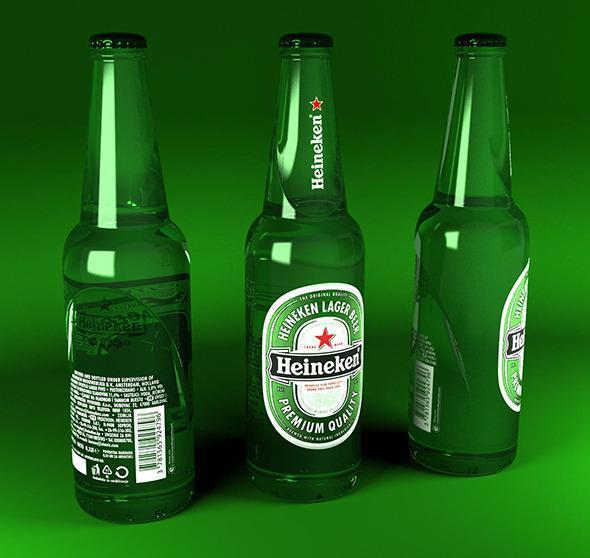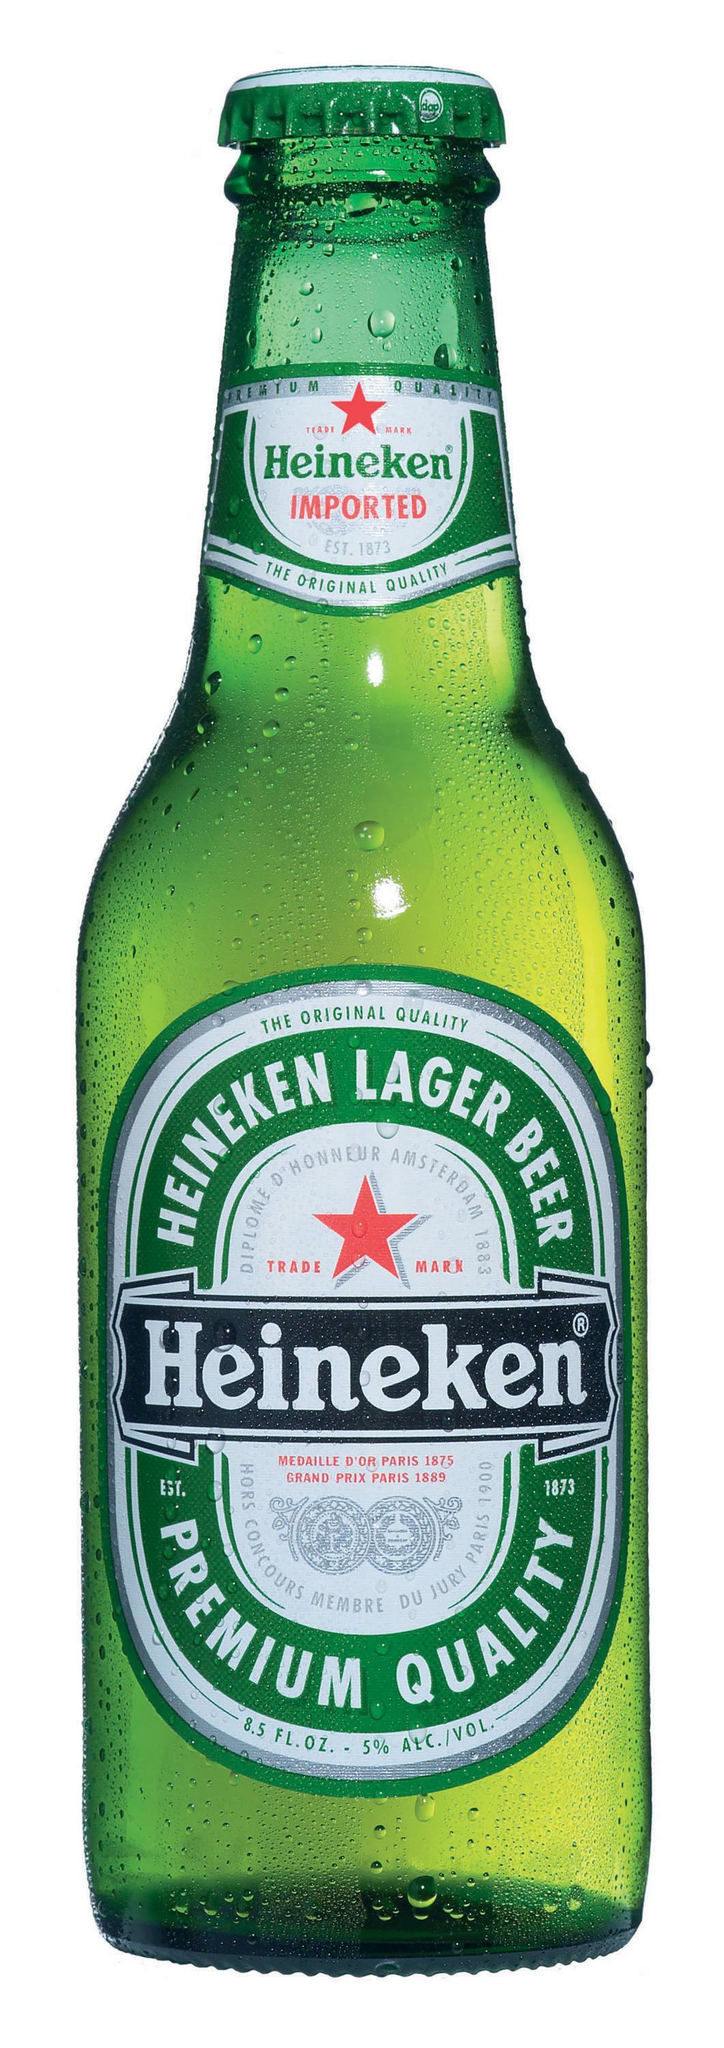The first image is the image on the left, the second image is the image on the right. For the images shown, is this caption "An image shows one stand-out bottle with its label clearly showing, amid at least a half dozen green bottles." true? Answer yes or no. No. The first image is the image on the left, the second image is the image on the right. Considering the images on both sides, is "In at least one image there are six green beer bottles." valid? Answer yes or no. No. 